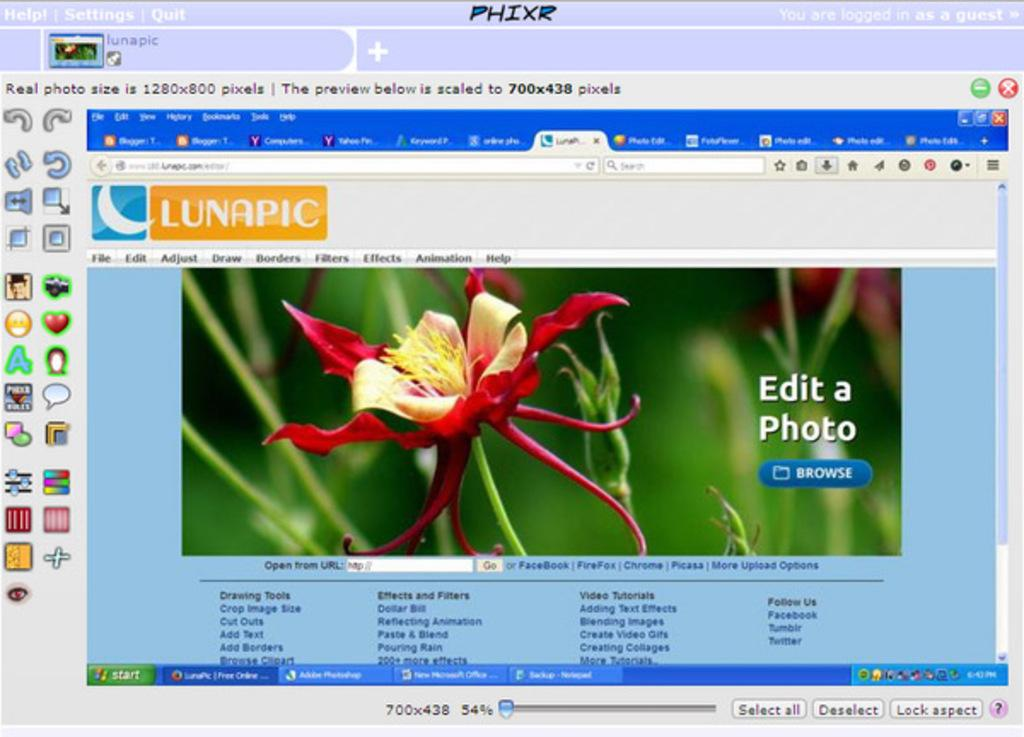What type of content is displayed in the image? The image is a web page. What visual element can be seen on the web page? There is a flower on the web page. What type of symbols are present on the web page? There are symbols on the web page. What interactive elements are available on the web page? There are buttons on the web page. What type of information is conveyed through text on the web page? There is text on the web page. What type of gate is visible on the web page? There is no gate present on the web page; it is a digital image and not a physical location. 